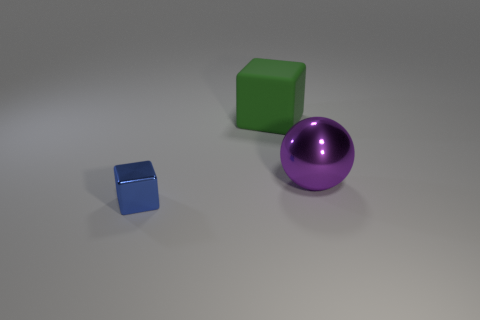How many other things are made of the same material as the big purple object?
Your response must be concise. 1. Is there anything else that has the same shape as the big matte object?
Ensure brevity in your answer.  Yes. The metal object right of the large object behind the shiny thing that is behind the small blue shiny object is what color?
Offer a terse response. Purple. There is a object that is both left of the large ball and behind the blue metal block; what is its shape?
Offer a very short reply. Cube. Is there anything else that has the same size as the metallic block?
Ensure brevity in your answer.  No. What is the color of the cube that is in front of the big thing to the right of the matte cube?
Give a very brief answer. Blue. What is the shape of the large shiny object that is in front of the object behind the large object to the right of the big green rubber block?
Your answer should be very brief. Sphere. There is a object that is both on the left side of the large purple metallic object and in front of the big matte cube; how big is it?
Make the answer very short. Small. What number of big things have the same color as the small metallic thing?
Your answer should be very brief. 0. What is the large cube made of?
Your response must be concise. Rubber. 